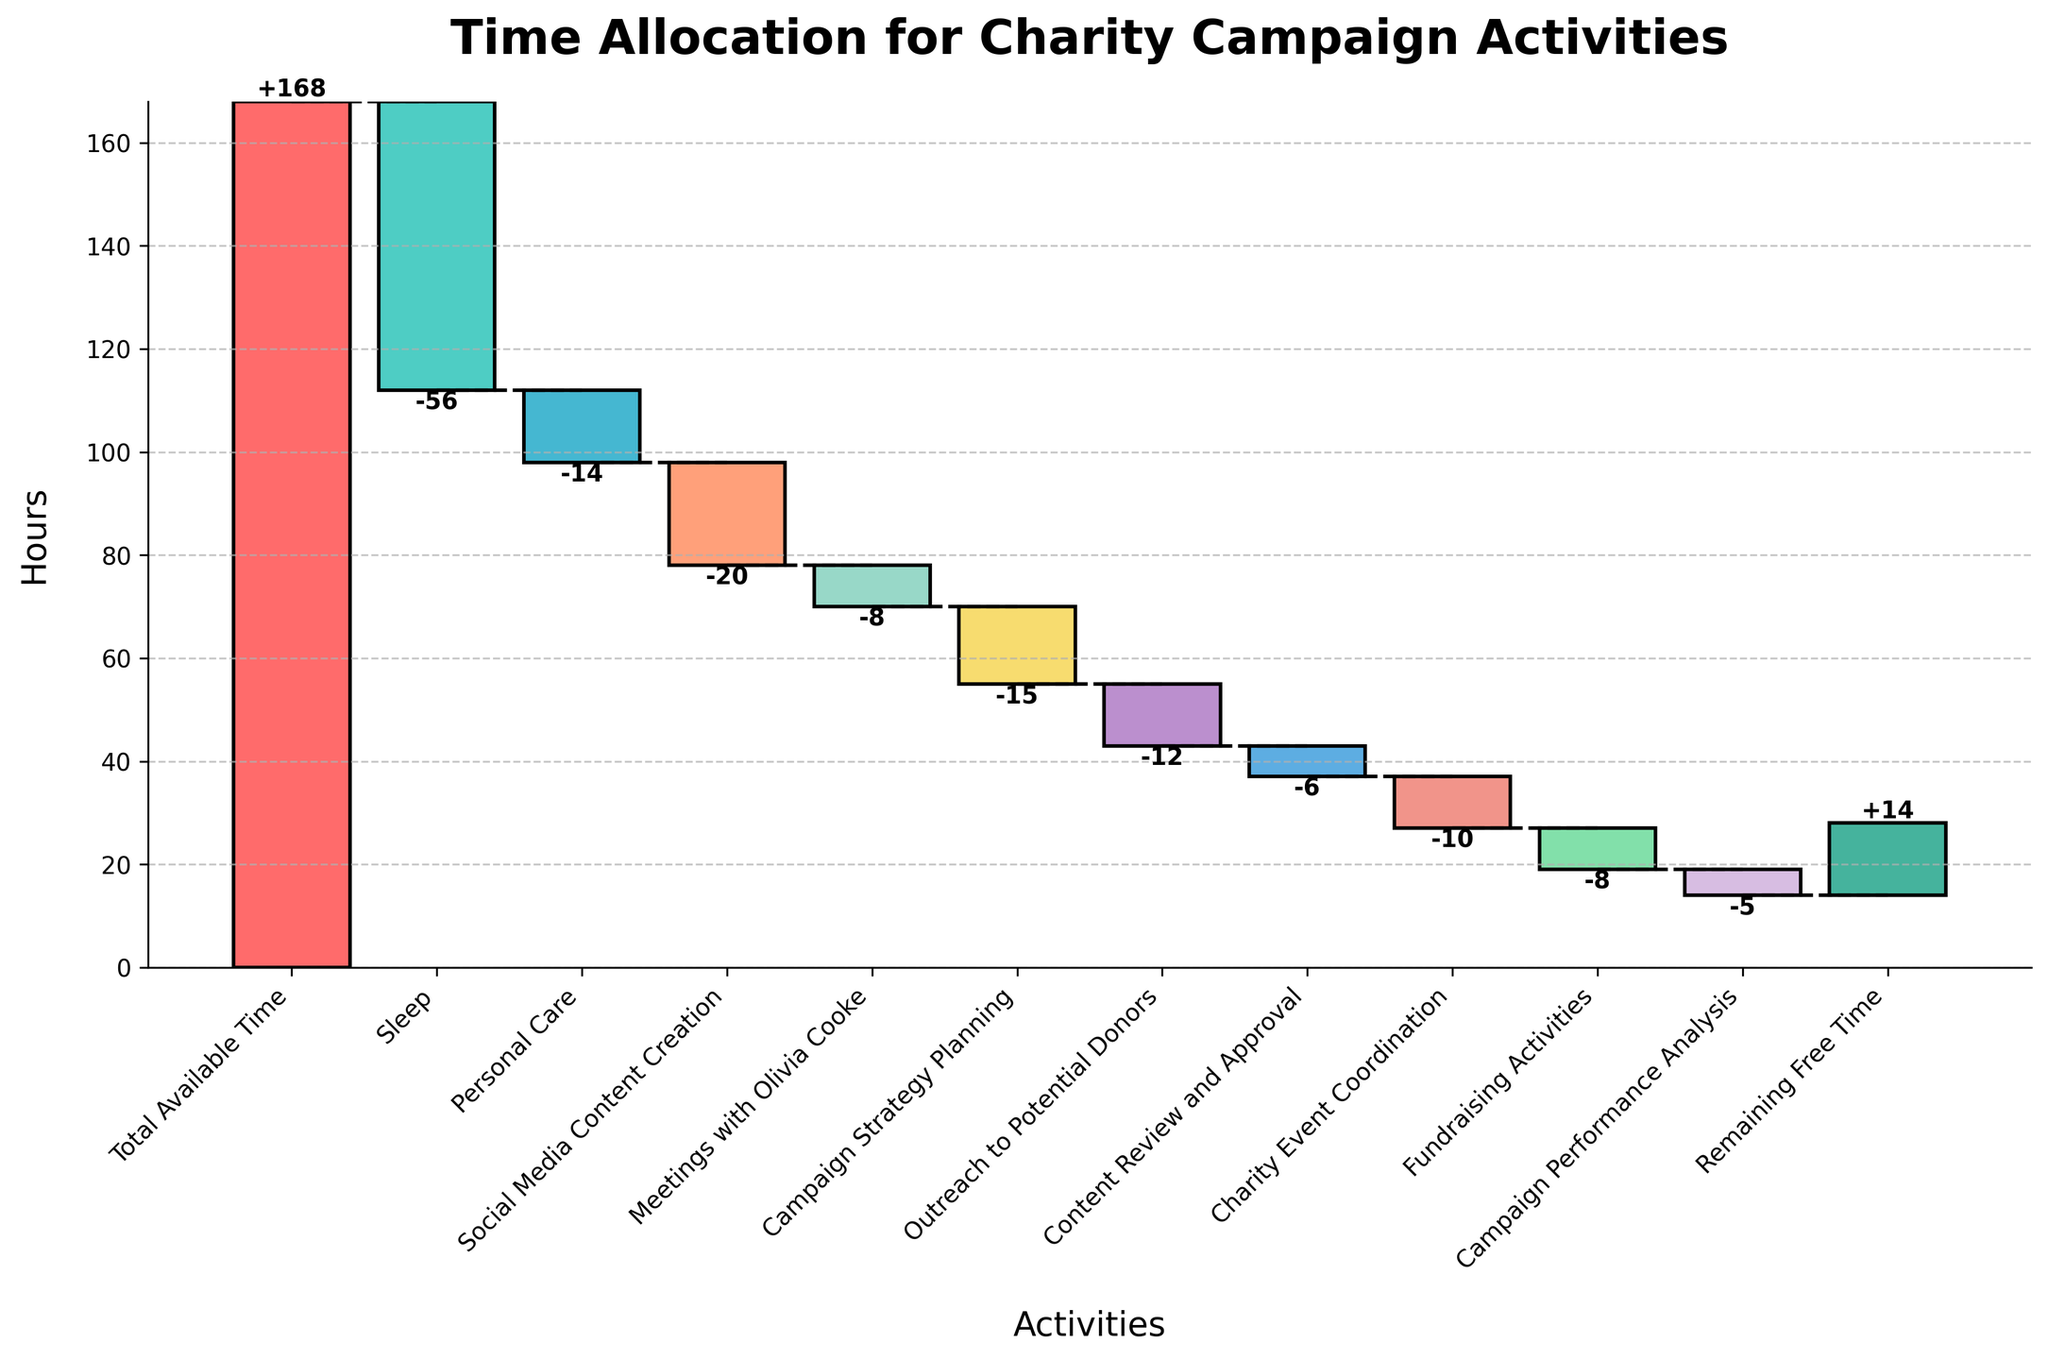How many hours are allocated to Sleep in the week? The bar labeled "Sleep" indicates the number of hours allocated to sleep as -56.
Answer: 56 hours What is the total available time for the week? The first bar labeled "Total Available Time" shows that the total available time for the week is 168 hours.
Answer: 168 hours What activity takes the most time after Sleep? Comparing all the activity bars after "Sleep," "Social Media Content Creation" takes the most time with -20 hours.
Answer: Social Media Content Creation How much remaining free time is available at the end of the week? The last bar is labeled "Remaining Free Time," showing 14 hours of free time remaining.
Answer: 14 hours Which activities take less than 10 hours each? The bars for "Meetings with Olivia Cooke," "Content Review and Approval," "Campaign Performance Analysis," and "Fundraising Activities" are all less than 10 hours each.
Answer: Meetings with Olivia Cooke, Content Review and Approval, Campaign Performance Analysis, Fundraising Activities By how much does the time spent on Campaign Strategy Planning exceed the time spent on Outreach to Potential Donors? Campaign Strategy Planning is -15 hours, whereas Outreach to Potential Donors is -12 hours. The difference is 15 - 12 = 3 hours.
Answer: 3 hours What is the difference in hours between Charity Event Coordination and Fundraising Activities? Charity Event Coordination takes -10 hours, and Fundraising Activities take -8 hours. The difference is 10 - 8 = 2 hours.
Answer: 2 hours If you combine the time spent on Personal Care and Social Media Content Creation, how many hours are allocated? Personal Care is -14 hours, and Social Media Content Creation is -20 hours. The sum is 14 + 20 = 34 hours.
Answer: 34 hours What is the cumulative number of hours after all activities are accounted for? The total cumulative time starts with 168 hours and subtracts all activity hours, leaving 14 hours of remaining free time.
Answer: 14 hours 